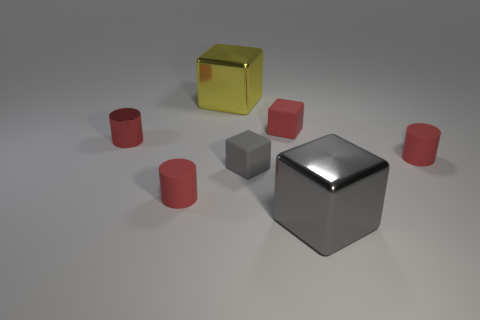Is there any other thing that has the same size as the yellow metal thing?
Give a very brief answer. Yes. Is the yellow metal thing the same shape as the tiny gray rubber object?
Keep it short and to the point. Yes. What is the color of the small metal cylinder?
Make the answer very short. Red. How many small things are either red metal cylinders or matte cylinders?
Provide a short and direct response. 3. Does the red object on the right side of the small red matte cube have the same size as the metallic block in front of the big yellow thing?
Offer a terse response. No. The red rubber thing that is the same shape as the large yellow object is what size?
Provide a succinct answer. Small. Is the number of metal objects that are in front of the small red shiny object greater than the number of red rubber objects that are behind the red matte block?
Your response must be concise. Yes. There is a thing that is behind the tiny red metallic cylinder and to the right of the large yellow object; what material is it?
Your answer should be very brief. Rubber. What is the color of the other metal object that is the same shape as the big yellow thing?
Make the answer very short. Gray. What size is the gray metallic thing?
Give a very brief answer. Large. 